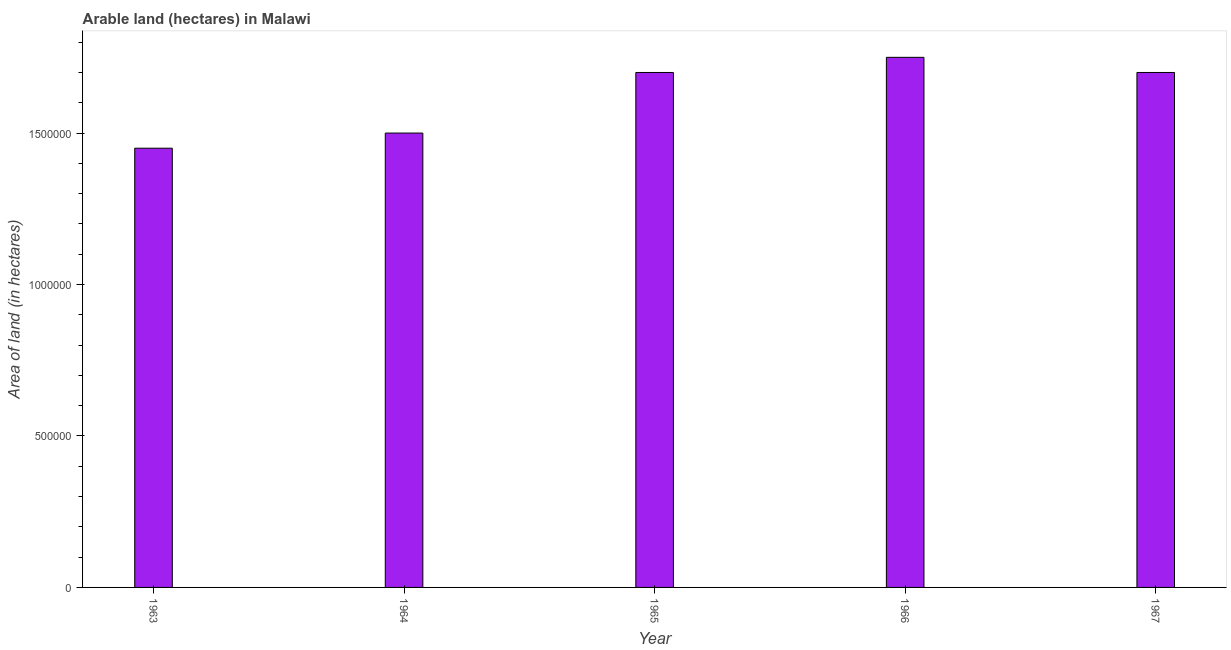What is the title of the graph?
Offer a terse response. Arable land (hectares) in Malawi. What is the label or title of the X-axis?
Ensure brevity in your answer.  Year. What is the label or title of the Y-axis?
Make the answer very short. Area of land (in hectares). What is the area of land in 1965?
Ensure brevity in your answer.  1.70e+06. Across all years, what is the maximum area of land?
Provide a short and direct response. 1.75e+06. Across all years, what is the minimum area of land?
Make the answer very short. 1.45e+06. In which year was the area of land maximum?
Provide a succinct answer. 1966. What is the sum of the area of land?
Provide a short and direct response. 8.10e+06. What is the difference between the area of land in 1964 and 1965?
Your response must be concise. -2.00e+05. What is the average area of land per year?
Give a very brief answer. 1.62e+06. What is the median area of land?
Provide a short and direct response. 1.70e+06. In how many years, is the area of land greater than 100000 hectares?
Your answer should be very brief. 5. What is the ratio of the area of land in 1964 to that in 1967?
Your response must be concise. 0.88. What is the difference between the highest and the lowest area of land?
Provide a short and direct response. 3.00e+05. In how many years, is the area of land greater than the average area of land taken over all years?
Provide a short and direct response. 3. How many bars are there?
Your answer should be compact. 5. How many years are there in the graph?
Ensure brevity in your answer.  5. What is the difference between two consecutive major ticks on the Y-axis?
Make the answer very short. 5.00e+05. What is the Area of land (in hectares) of 1963?
Offer a very short reply. 1.45e+06. What is the Area of land (in hectares) of 1964?
Your response must be concise. 1.50e+06. What is the Area of land (in hectares) of 1965?
Make the answer very short. 1.70e+06. What is the Area of land (in hectares) in 1966?
Make the answer very short. 1.75e+06. What is the Area of land (in hectares) in 1967?
Your answer should be compact. 1.70e+06. What is the difference between the Area of land (in hectares) in 1963 and 1964?
Provide a short and direct response. -5.00e+04. What is the difference between the Area of land (in hectares) in 1963 and 1965?
Offer a very short reply. -2.50e+05. What is the difference between the Area of land (in hectares) in 1963 and 1966?
Provide a succinct answer. -3.00e+05. What is the difference between the Area of land (in hectares) in 1964 and 1967?
Provide a short and direct response. -2.00e+05. What is the difference between the Area of land (in hectares) in 1965 and 1966?
Your response must be concise. -5.00e+04. What is the ratio of the Area of land (in hectares) in 1963 to that in 1964?
Provide a short and direct response. 0.97. What is the ratio of the Area of land (in hectares) in 1963 to that in 1965?
Offer a terse response. 0.85. What is the ratio of the Area of land (in hectares) in 1963 to that in 1966?
Ensure brevity in your answer.  0.83. What is the ratio of the Area of land (in hectares) in 1963 to that in 1967?
Offer a terse response. 0.85. What is the ratio of the Area of land (in hectares) in 1964 to that in 1965?
Offer a very short reply. 0.88. What is the ratio of the Area of land (in hectares) in 1964 to that in 1966?
Ensure brevity in your answer.  0.86. What is the ratio of the Area of land (in hectares) in 1964 to that in 1967?
Your answer should be compact. 0.88. 